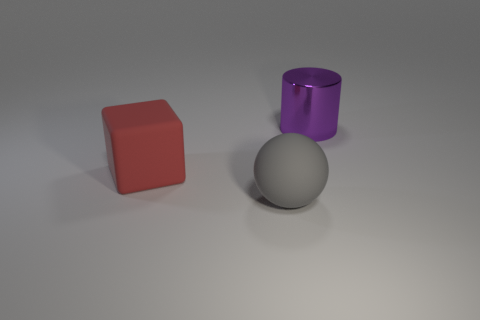Add 2 big cyan matte objects. How many objects exist? 5 Subtract all spheres. How many objects are left? 2 Subtract all purple shiny things. Subtract all big rubber objects. How many objects are left? 0 Add 3 gray spheres. How many gray spheres are left? 4 Add 3 blocks. How many blocks exist? 4 Subtract 0 gray cylinders. How many objects are left? 3 